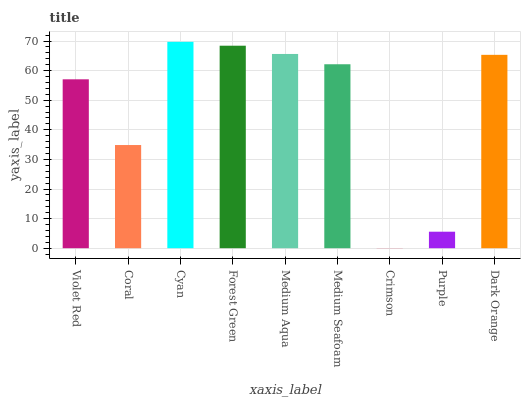Is Crimson the minimum?
Answer yes or no. Yes. Is Cyan the maximum?
Answer yes or no. Yes. Is Coral the minimum?
Answer yes or no. No. Is Coral the maximum?
Answer yes or no. No. Is Violet Red greater than Coral?
Answer yes or no. Yes. Is Coral less than Violet Red?
Answer yes or no. Yes. Is Coral greater than Violet Red?
Answer yes or no. No. Is Violet Red less than Coral?
Answer yes or no. No. Is Medium Seafoam the high median?
Answer yes or no. Yes. Is Medium Seafoam the low median?
Answer yes or no. Yes. Is Coral the high median?
Answer yes or no. No. Is Coral the low median?
Answer yes or no. No. 